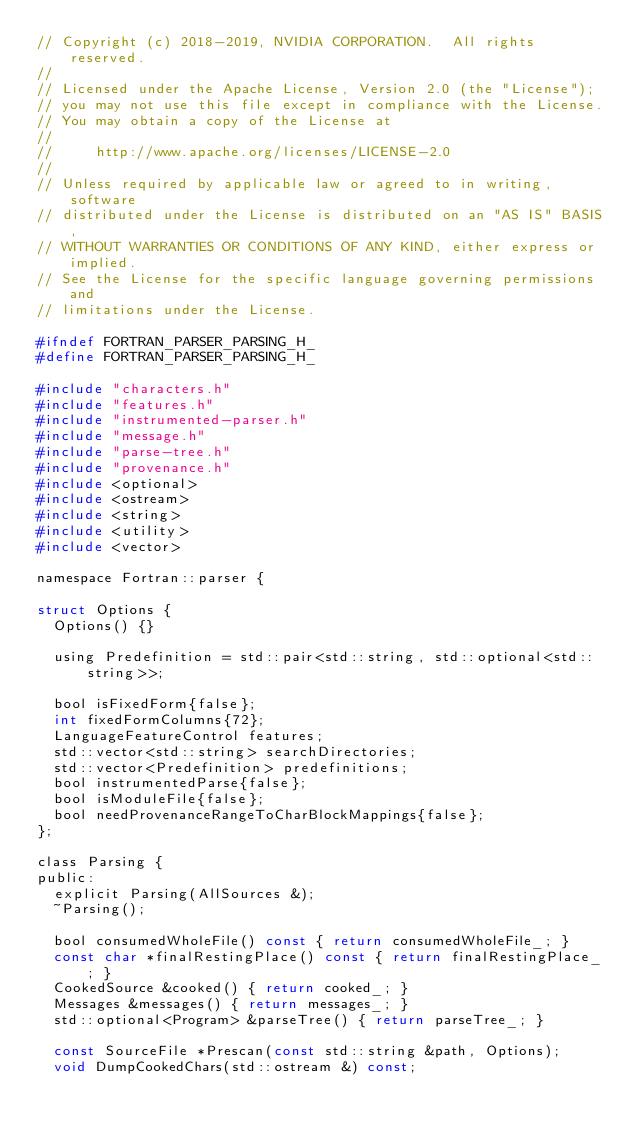<code> <loc_0><loc_0><loc_500><loc_500><_C_>// Copyright (c) 2018-2019, NVIDIA CORPORATION.  All rights reserved.
//
// Licensed under the Apache License, Version 2.0 (the "License");
// you may not use this file except in compliance with the License.
// You may obtain a copy of the License at
//
//     http://www.apache.org/licenses/LICENSE-2.0
//
// Unless required by applicable law or agreed to in writing, software
// distributed under the License is distributed on an "AS IS" BASIS,
// WITHOUT WARRANTIES OR CONDITIONS OF ANY KIND, either express or implied.
// See the License for the specific language governing permissions and
// limitations under the License.

#ifndef FORTRAN_PARSER_PARSING_H_
#define FORTRAN_PARSER_PARSING_H_

#include "characters.h"
#include "features.h"
#include "instrumented-parser.h"
#include "message.h"
#include "parse-tree.h"
#include "provenance.h"
#include <optional>
#include <ostream>
#include <string>
#include <utility>
#include <vector>

namespace Fortran::parser {

struct Options {
  Options() {}

  using Predefinition = std::pair<std::string, std::optional<std::string>>;

  bool isFixedForm{false};
  int fixedFormColumns{72};
  LanguageFeatureControl features;
  std::vector<std::string> searchDirectories;
  std::vector<Predefinition> predefinitions;
  bool instrumentedParse{false};
  bool isModuleFile{false};
  bool needProvenanceRangeToCharBlockMappings{false};
};

class Parsing {
public:
  explicit Parsing(AllSources &);
  ~Parsing();

  bool consumedWholeFile() const { return consumedWholeFile_; }
  const char *finalRestingPlace() const { return finalRestingPlace_; }
  CookedSource &cooked() { return cooked_; }
  Messages &messages() { return messages_; }
  std::optional<Program> &parseTree() { return parseTree_; }

  const SourceFile *Prescan(const std::string &path, Options);
  void DumpCookedChars(std::ostream &) const;</code> 